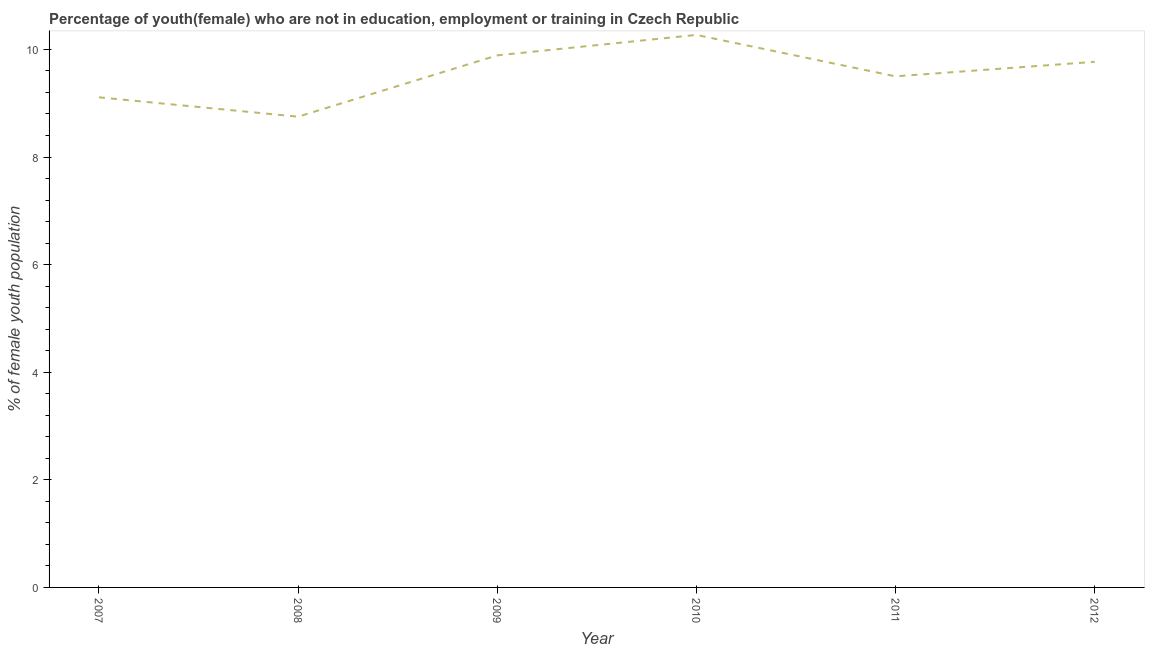What is the unemployed female youth population in 2008?
Keep it short and to the point. 8.75. Across all years, what is the maximum unemployed female youth population?
Keep it short and to the point. 10.27. Across all years, what is the minimum unemployed female youth population?
Provide a short and direct response. 8.75. In which year was the unemployed female youth population maximum?
Offer a very short reply. 2010. In which year was the unemployed female youth population minimum?
Ensure brevity in your answer.  2008. What is the sum of the unemployed female youth population?
Keep it short and to the point. 57.29. What is the difference between the unemployed female youth population in 2008 and 2010?
Provide a short and direct response. -1.52. What is the average unemployed female youth population per year?
Provide a short and direct response. 9.55. What is the median unemployed female youth population?
Offer a terse response. 9.64. Do a majority of the years between 2007 and 2008 (inclusive) have unemployed female youth population greater than 7.2 %?
Your answer should be compact. Yes. What is the ratio of the unemployed female youth population in 2008 to that in 2012?
Offer a very short reply. 0.9. Is the unemployed female youth population in 2010 less than that in 2011?
Offer a terse response. No. What is the difference between the highest and the second highest unemployed female youth population?
Make the answer very short. 0.38. What is the difference between the highest and the lowest unemployed female youth population?
Offer a terse response. 1.52. Does the unemployed female youth population monotonically increase over the years?
Your answer should be compact. No. How many lines are there?
Offer a terse response. 1. What is the difference between two consecutive major ticks on the Y-axis?
Offer a very short reply. 2. Are the values on the major ticks of Y-axis written in scientific E-notation?
Provide a short and direct response. No. Does the graph contain any zero values?
Make the answer very short. No. Does the graph contain grids?
Your answer should be very brief. No. What is the title of the graph?
Make the answer very short. Percentage of youth(female) who are not in education, employment or training in Czech Republic. What is the label or title of the X-axis?
Make the answer very short. Year. What is the label or title of the Y-axis?
Your response must be concise. % of female youth population. What is the % of female youth population of 2007?
Your answer should be very brief. 9.11. What is the % of female youth population in 2008?
Keep it short and to the point. 8.75. What is the % of female youth population in 2009?
Give a very brief answer. 9.89. What is the % of female youth population of 2010?
Your answer should be compact. 10.27. What is the % of female youth population of 2011?
Provide a short and direct response. 9.5. What is the % of female youth population of 2012?
Your answer should be compact. 9.77. What is the difference between the % of female youth population in 2007 and 2008?
Keep it short and to the point. 0.36. What is the difference between the % of female youth population in 2007 and 2009?
Ensure brevity in your answer.  -0.78. What is the difference between the % of female youth population in 2007 and 2010?
Offer a terse response. -1.16. What is the difference between the % of female youth population in 2007 and 2011?
Keep it short and to the point. -0.39. What is the difference between the % of female youth population in 2007 and 2012?
Make the answer very short. -0.66. What is the difference between the % of female youth population in 2008 and 2009?
Your answer should be very brief. -1.14. What is the difference between the % of female youth population in 2008 and 2010?
Make the answer very short. -1.52. What is the difference between the % of female youth population in 2008 and 2011?
Offer a terse response. -0.75. What is the difference between the % of female youth population in 2008 and 2012?
Make the answer very short. -1.02. What is the difference between the % of female youth population in 2009 and 2010?
Offer a terse response. -0.38. What is the difference between the % of female youth population in 2009 and 2011?
Provide a succinct answer. 0.39. What is the difference between the % of female youth population in 2009 and 2012?
Offer a very short reply. 0.12. What is the difference between the % of female youth population in 2010 and 2011?
Provide a succinct answer. 0.77. What is the difference between the % of female youth population in 2010 and 2012?
Offer a terse response. 0.5. What is the difference between the % of female youth population in 2011 and 2012?
Offer a very short reply. -0.27. What is the ratio of the % of female youth population in 2007 to that in 2008?
Offer a terse response. 1.04. What is the ratio of the % of female youth population in 2007 to that in 2009?
Ensure brevity in your answer.  0.92. What is the ratio of the % of female youth population in 2007 to that in 2010?
Your answer should be very brief. 0.89. What is the ratio of the % of female youth population in 2007 to that in 2011?
Provide a short and direct response. 0.96. What is the ratio of the % of female youth population in 2007 to that in 2012?
Offer a terse response. 0.93. What is the ratio of the % of female youth population in 2008 to that in 2009?
Offer a very short reply. 0.89. What is the ratio of the % of female youth population in 2008 to that in 2010?
Your answer should be compact. 0.85. What is the ratio of the % of female youth population in 2008 to that in 2011?
Provide a succinct answer. 0.92. What is the ratio of the % of female youth population in 2008 to that in 2012?
Offer a terse response. 0.9. What is the ratio of the % of female youth population in 2009 to that in 2010?
Offer a terse response. 0.96. What is the ratio of the % of female youth population in 2009 to that in 2011?
Offer a terse response. 1.04. What is the ratio of the % of female youth population in 2010 to that in 2011?
Offer a very short reply. 1.08. What is the ratio of the % of female youth population in 2010 to that in 2012?
Give a very brief answer. 1.05. What is the ratio of the % of female youth population in 2011 to that in 2012?
Give a very brief answer. 0.97. 